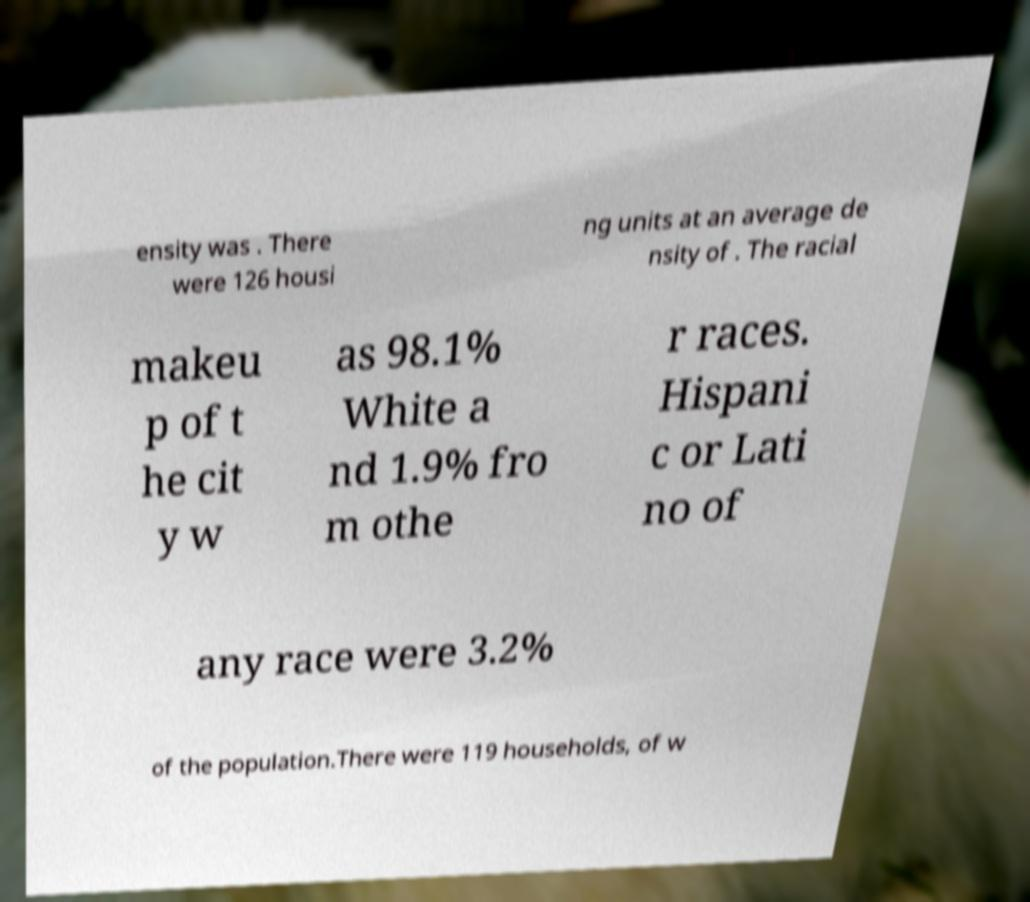Can you accurately transcribe the text from the provided image for me? ensity was . There were 126 housi ng units at an average de nsity of . The racial makeu p of t he cit y w as 98.1% White a nd 1.9% fro m othe r races. Hispani c or Lati no of any race were 3.2% of the population.There were 119 households, of w 